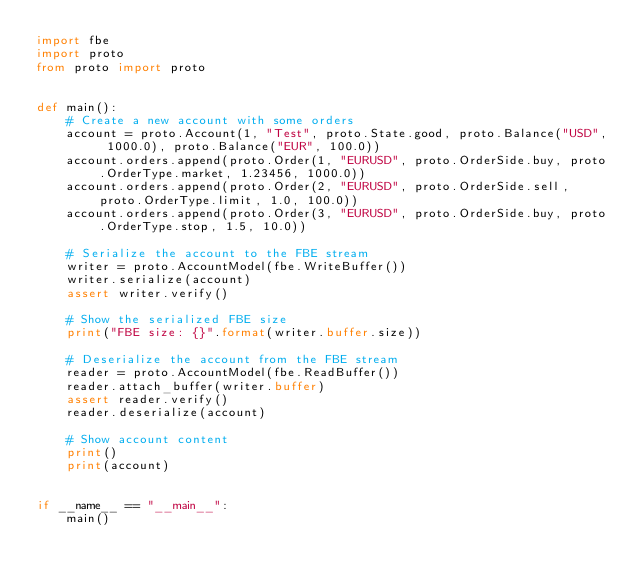Convert code to text. <code><loc_0><loc_0><loc_500><loc_500><_Python_>import fbe
import proto
from proto import proto


def main():
    # Create a new account with some orders
    account = proto.Account(1, "Test", proto.State.good, proto.Balance("USD", 1000.0), proto.Balance("EUR", 100.0))
    account.orders.append(proto.Order(1, "EURUSD", proto.OrderSide.buy, proto.OrderType.market, 1.23456, 1000.0))
    account.orders.append(proto.Order(2, "EURUSD", proto.OrderSide.sell, proto.OrderType.limit, 1.0, 100.0))
    account.orders.append(proto.Order(3, "EURUSD", proto.OrderSide.buy, proto.OrderType.stop, 1.5, 10.0))

    # Serialize the account to the FBE stream
    writer = proto.AccountModel(fbe.WriteBuffer())
    writer.serialize(account)
    assert writer.verify()

    # Show the serialized FBE size
    print("FBE size: {}".format(writer.buffer.size))

    # Deserialize the account from the FBE stream
    reader = proto.AccountModel(fbe.ReadBuffer())
    reader.attach_buffer(writer.buffer)
    assert reader.verify()
    reader.deserialize(account)

    # Show account content
    print()
    print(account)


if __name__ == "__main__":
    main()
</code> 